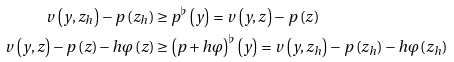<formula> <loc_0><loc_0><loc_500><loc_500>v \left ( y , z _ { h } \right ) - p \left ( z _ { h } \right ) & \geq p ^ { \flat } \left ( y \right ) = v \left ( y , z \right ) - p \left ( z \right ) \\ v \left ( y , z \right ) - p \left ( z \right ) - h \varphi \left ( z \right ) & \geq \left ( p + h \varphi \right ) ^ { \flat } \left ( y \right ) = v \left ( y , z _ { h } \right ) - p \left ( z _ { h } \right ) - h \varphi \left ( z _ { h } \right )</formula> 